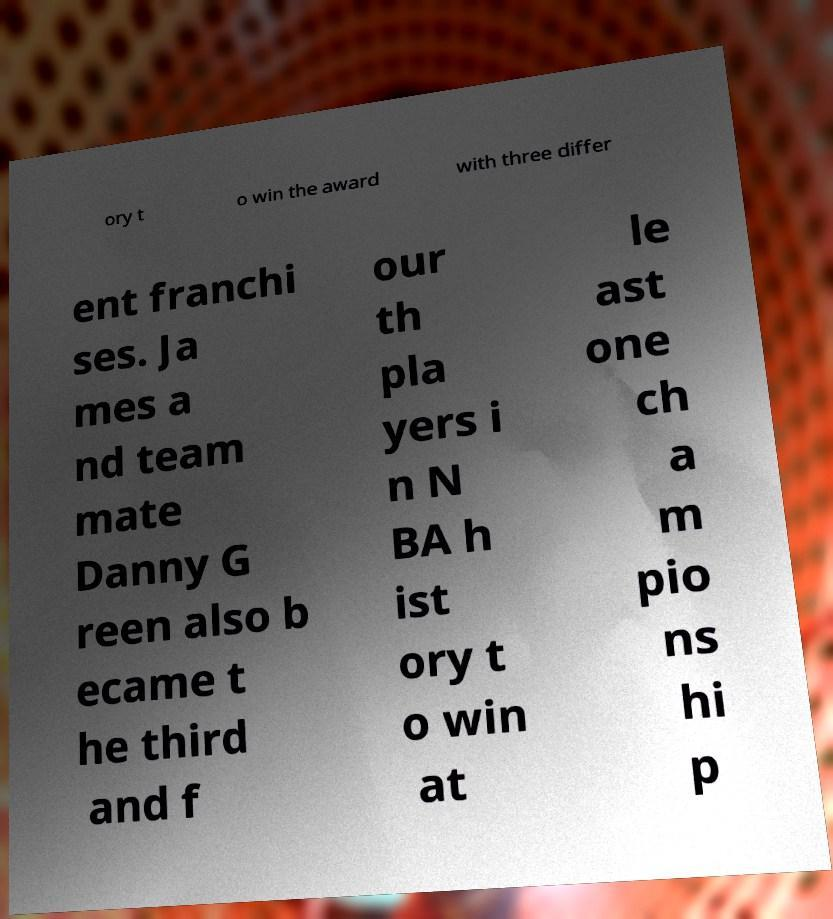Can you read and provide the text displayed in the image?This photo seems to have some interesting text. Can you extract and type it out for me? ory t o win the award with three differ ent franchi ses. Ja mes a nd team mate Danny G reen also b ecame t he third and f our th pla yers i n N BA h ist ory t o win at le ast one ch a m pio ns hi p 